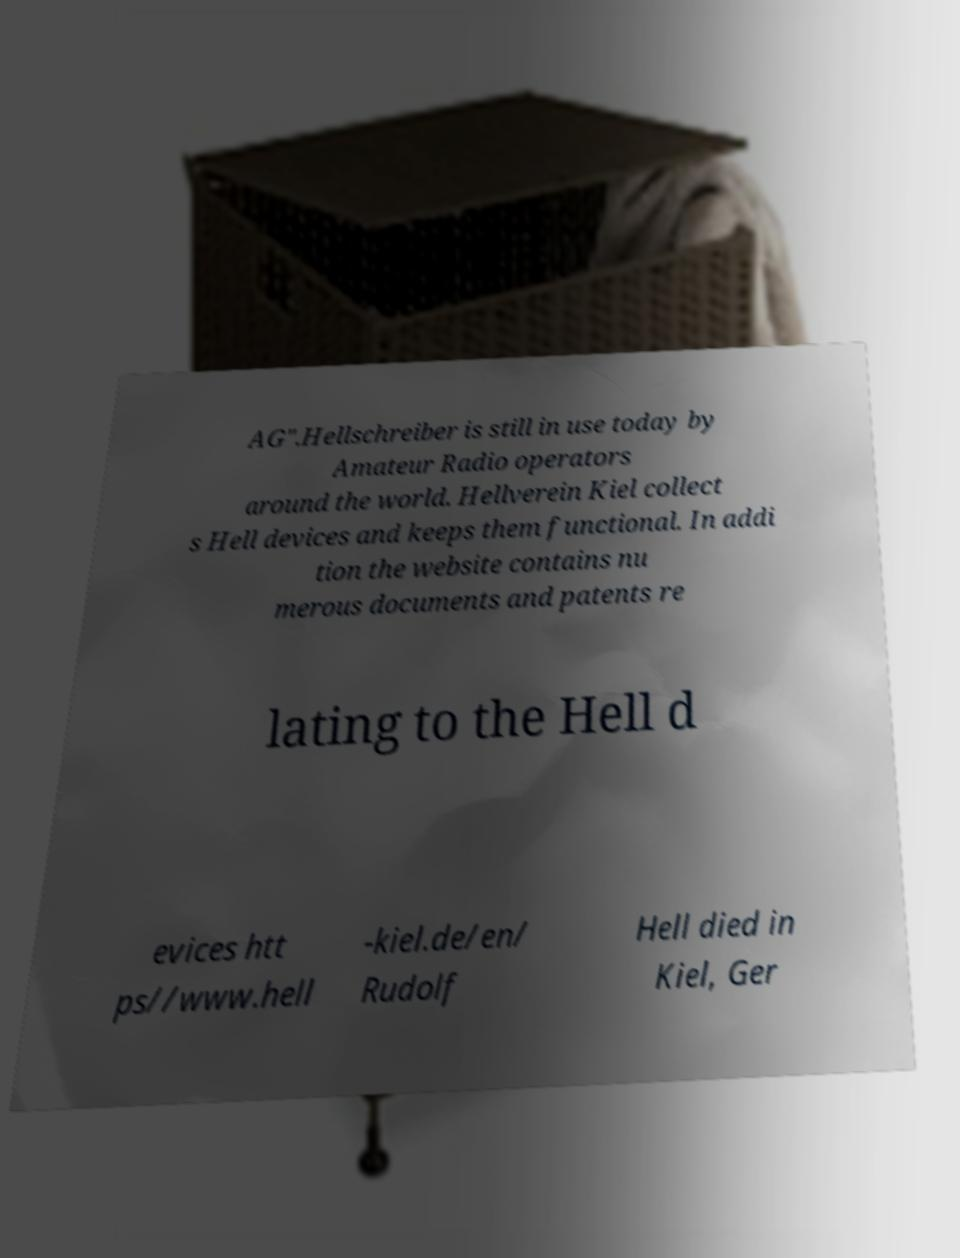Could you assist in decoding the text presented in this image and type it out clearly? AG".Hellschreiber is still in use today by Amateur Radio operators around the world. Hellverein Kiel collect s Hell devices and keeps them functional. In addi tion the website contains nu merous documents and patents re lating to the Hell d evices htt ps//www.hell -kiel.de/en/ Rudolf Hell died in Kiel, Ger 